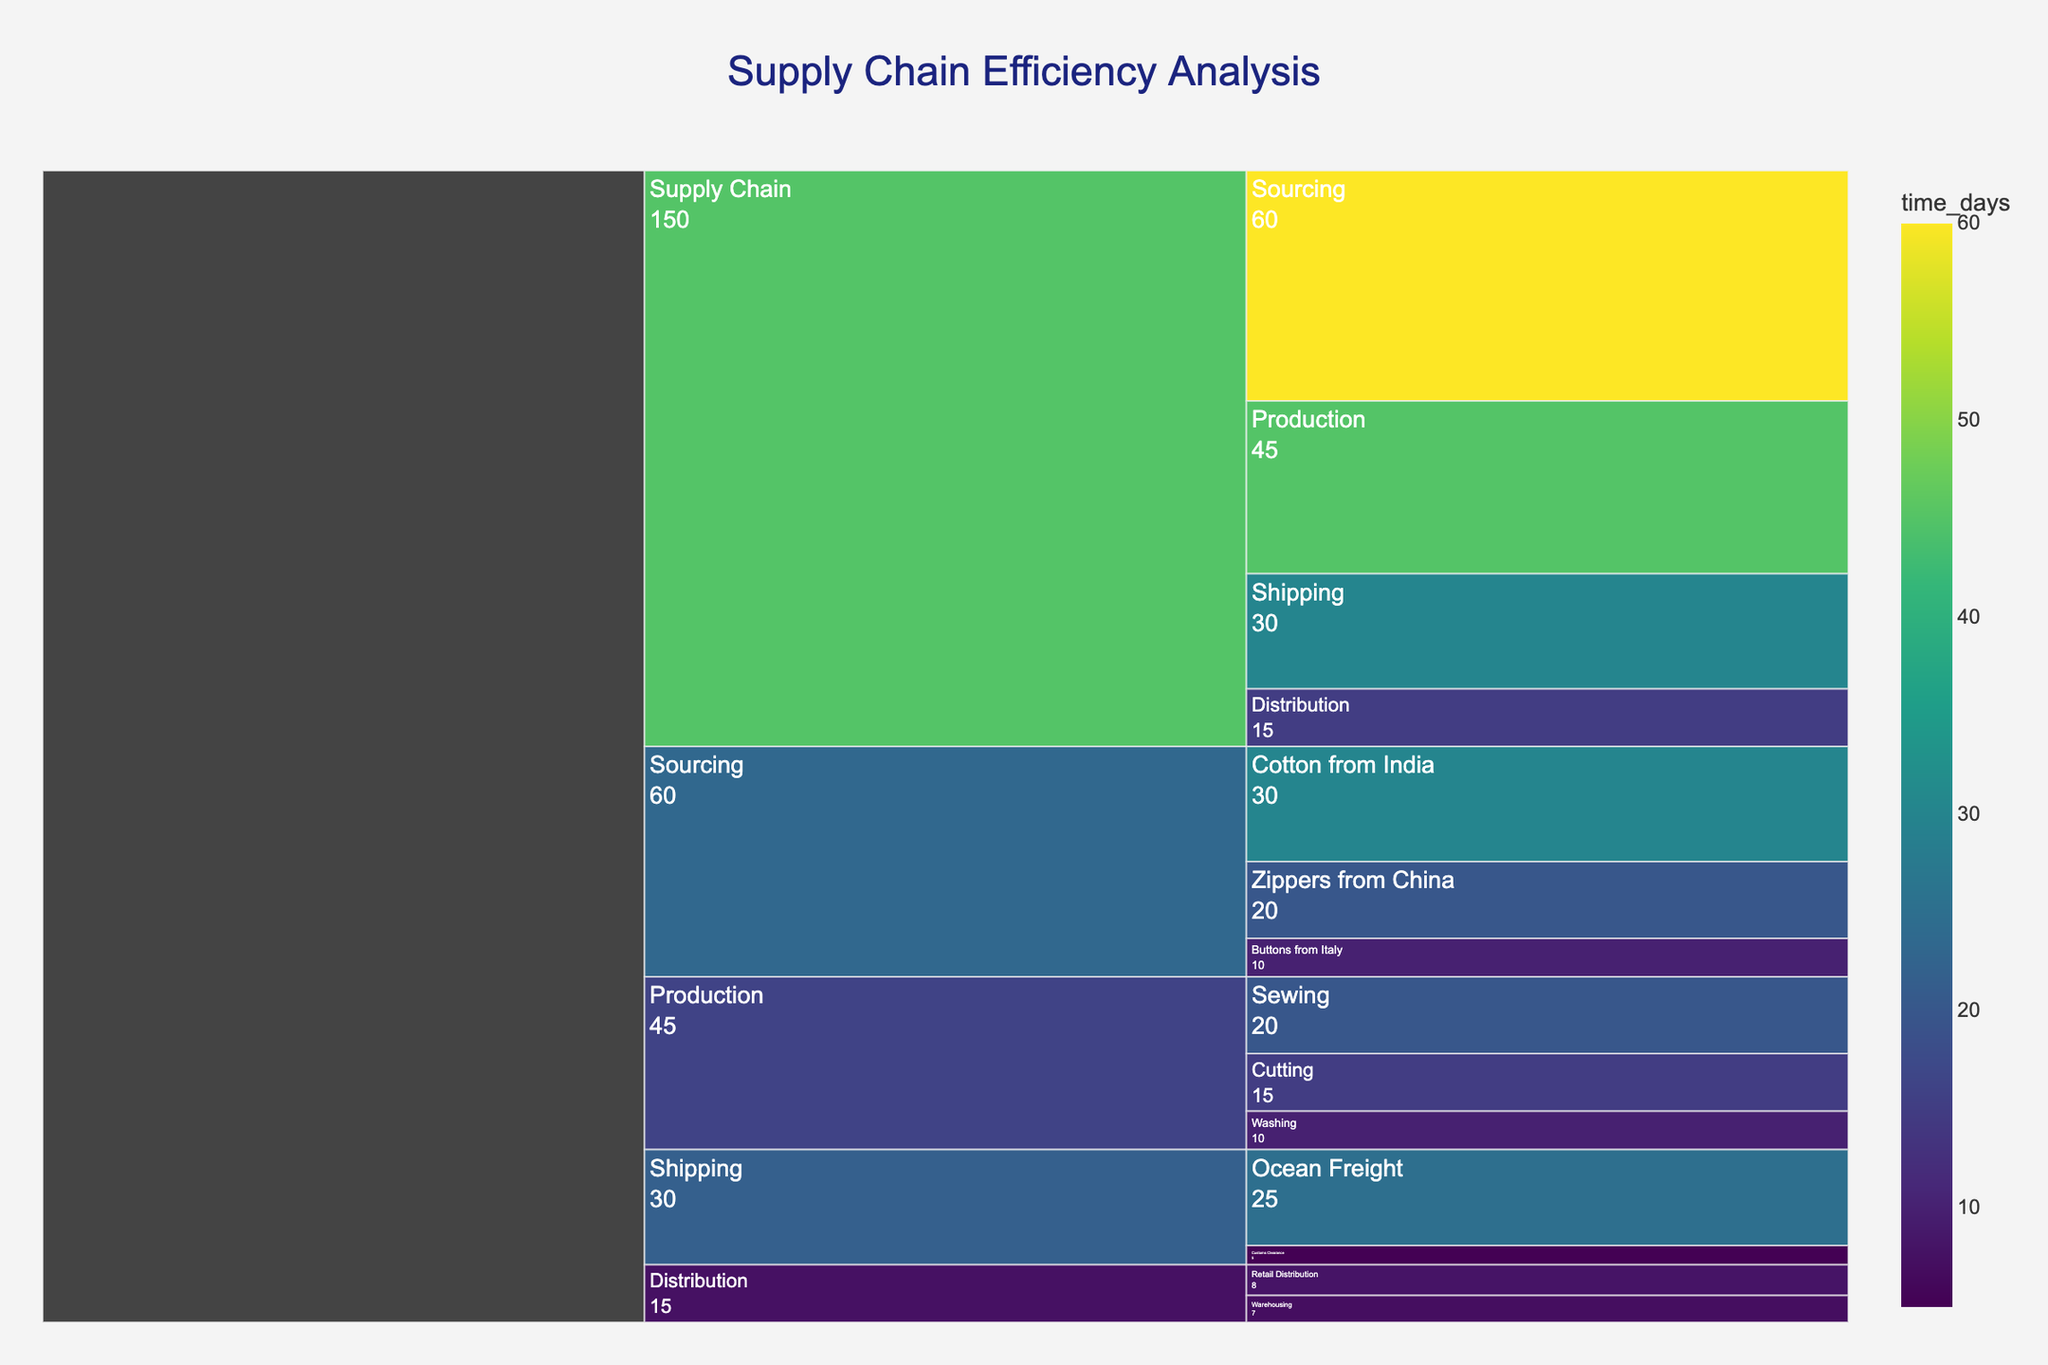What is the total time spent on sourcing materials? The Icicle Chart shows that the total time for sourcing (Cotton from India, Zippers from China, and Buttons from Italy) is the sum of individual times: 30 days + 20 days + 10 days.
Answer: 60 days Which stage of the supply chain takes the longest time? By comparing the visual lengths and time values, the sourcing stage has the highest total time, with each subcategory summing up to 60 days.
Answer: Sourcing How much more time is spent on shipping compared to distribution? The Icicle Chart shows 30 days for Shipping and 15 days for Distribution. The difference is 30 - 15.
Answer: 15 days What is the total time spent on production-related activities? Summing up the time for Cutting, Sewing, and Washing: 15 days + 20 days + 10 days.
Answer: 45 days What is the average time spent on each subcategory in the sourcing stage? There are three subcategories (Cotton, Zippers, Buttons) with times 30, 20, and 10 days. The average is (30 + 20 + 10) / 3.
Answer: 20 days Which specific activity in the shipping stage is the most time-consuming? The chart shows two activities: Ocean Freight (25 days) and Customs Clearance (5 days). Ocean Freight has the higher value.
Answer: Ocean Freight Compare the time spent on production versus the overall time spent on Supply Chain. Production time is 45 days. The total Supply Chain time is the sum of all categories (60 + 45 + 30 + 15). Since 45 is less than the total, Production takes less time.
Answer: Production takes 45 days, which is less than the overall 150 days Which stage has the smallest contribution to the total supply chain time? The chart shows Distribution time as 15 days. It's the smallest value among the categories.
Answer: Distribution How much time is spent in distribution compared to production? The chart shows 15 days for Distribution and 45 days for Production. The ratio of Distribution to Production is 15 / 45.
Answer: 1/3 Is the time spent in cutting greater than or equal to the time spent in washing? The chart shows Cutting at 15 days and Washing at 10 days. 15 days is greater than 10 days.
Answer: Greater 